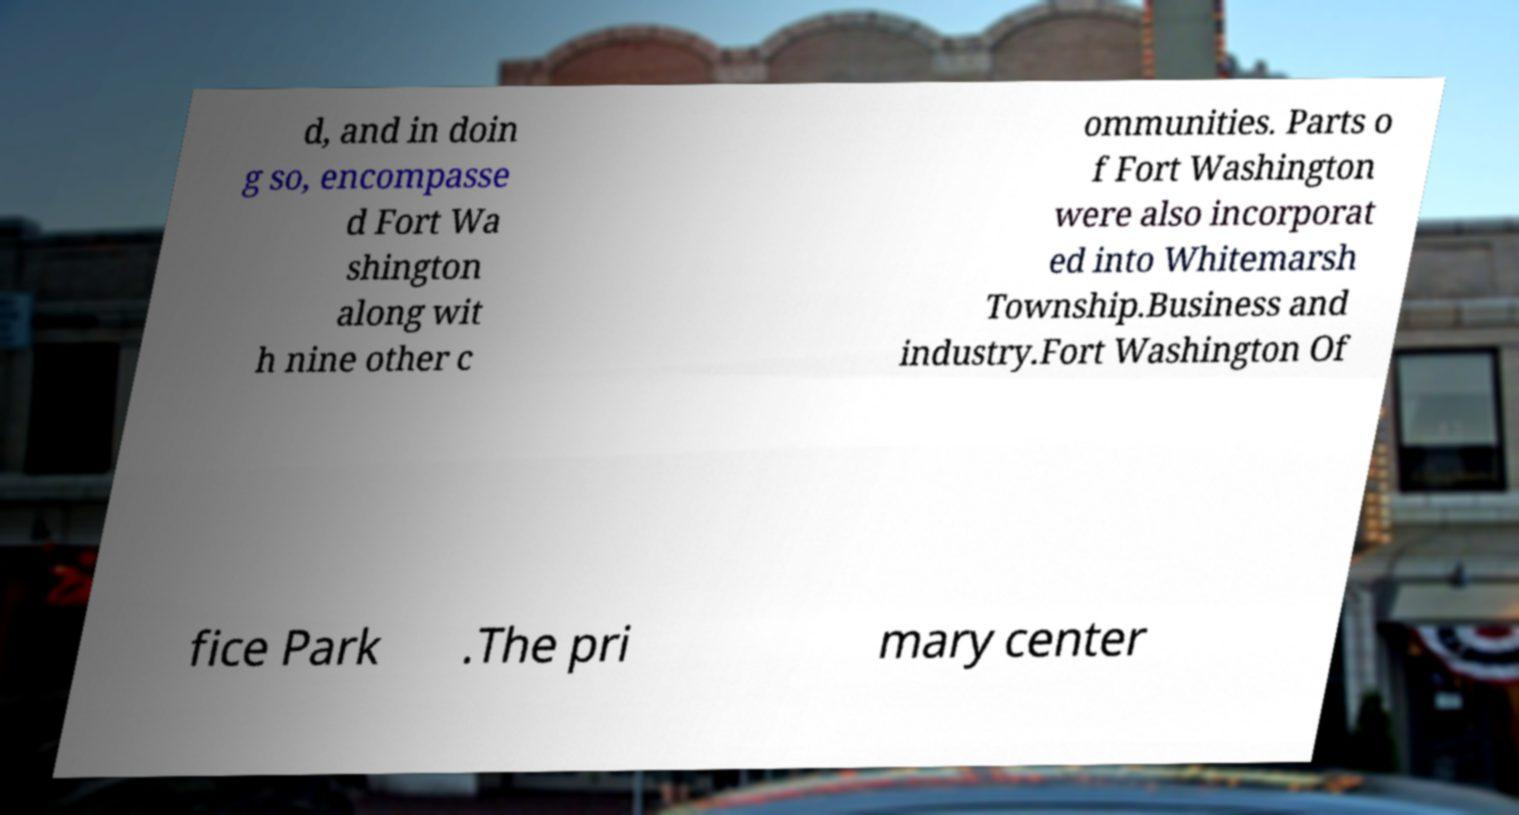I need the written content from this picture converted into text. Can you do that? d, and in doin g so, encompasse d Fort Wa shington along wit h nine other c ommunities. Parts o f Fort Washington were also incorporat ed into Whitemarsh Township.Business and industry.Fort Washington Of fice Park .The pri mary center 